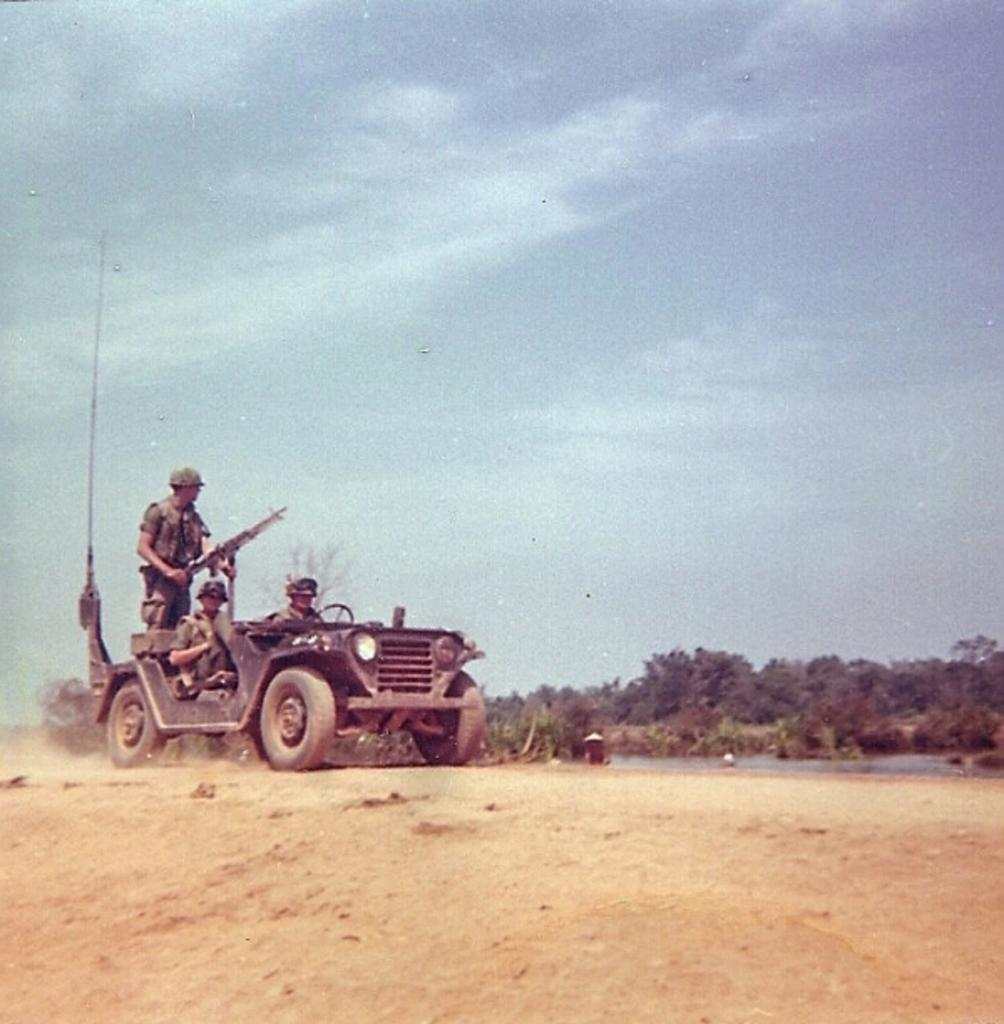How many people are in the image? There are three persons in the image. What are the persons doing in the image? The persons are riding on a car. Is there any object being held by one of the persons? Yes, one of the persons is holding a gun. What type of natural environment can be seen in the image? There are trees visible in the image. What is visible in the sky in the image? The sky is visible in the image. What type of pear is being used as a prop in the image? There is no pear present in the image. How does the beginner level of the persons affect their ability to ride the car in the image? The facts provided do not mention the skill level of the persons, so it cannot be determined if they are beginners or not. 